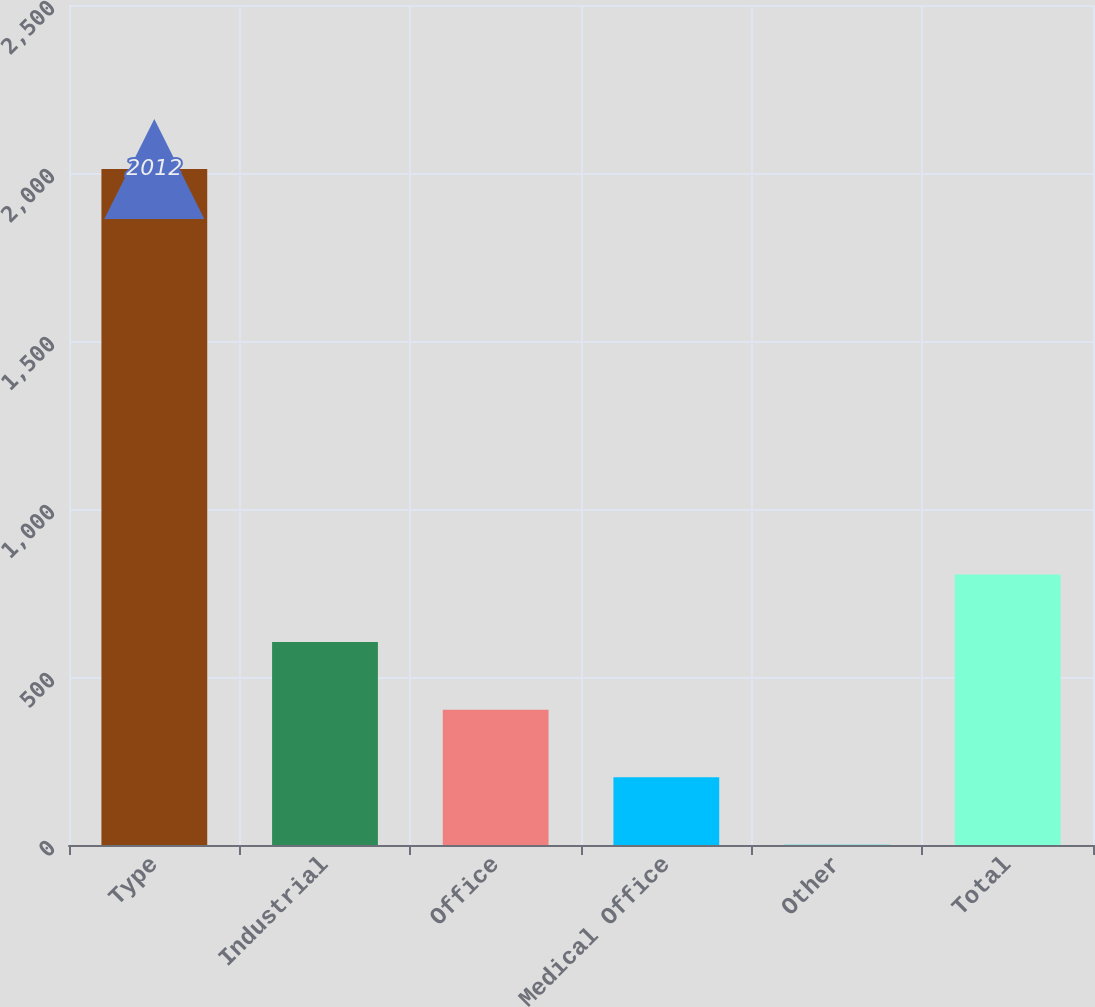<chart> <loc_0><loc_0><loc_500><loc_500><bar_chart><fcel>Type<fcel>Industrial<fcel>Office<fcel>Medical Office<fcel>Other<fcel>Total<nl><fcel>2012<fcel>604.02<fcel>402.88<fcel>201.74<fcel>0.6<fcel>805.16<nl></chart> 